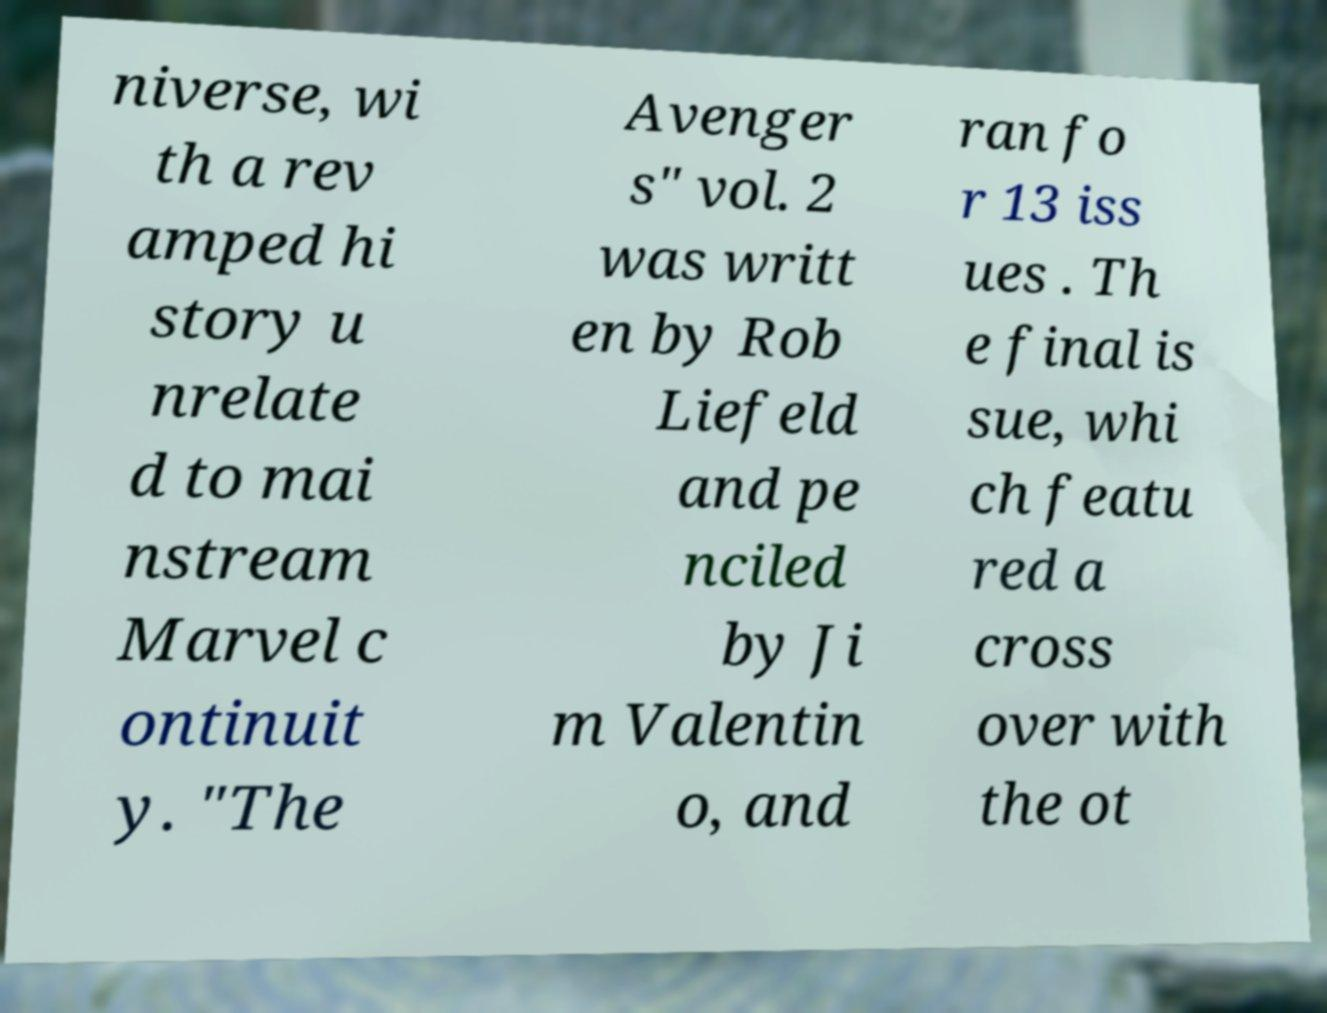I need the written content from this picture converted into text. Can you do that? niverse, wi th a rev amped hi story u nrelate d to mai nstream Marvel c ontinuit y. "The Avenger s" vol. 2 was writt en by Rob Liefeld and pe nciled by Ji m Valentin o, and ran fo r 13 iss ues . Th e final is sue, whi ch featu red a cross over with the ot 